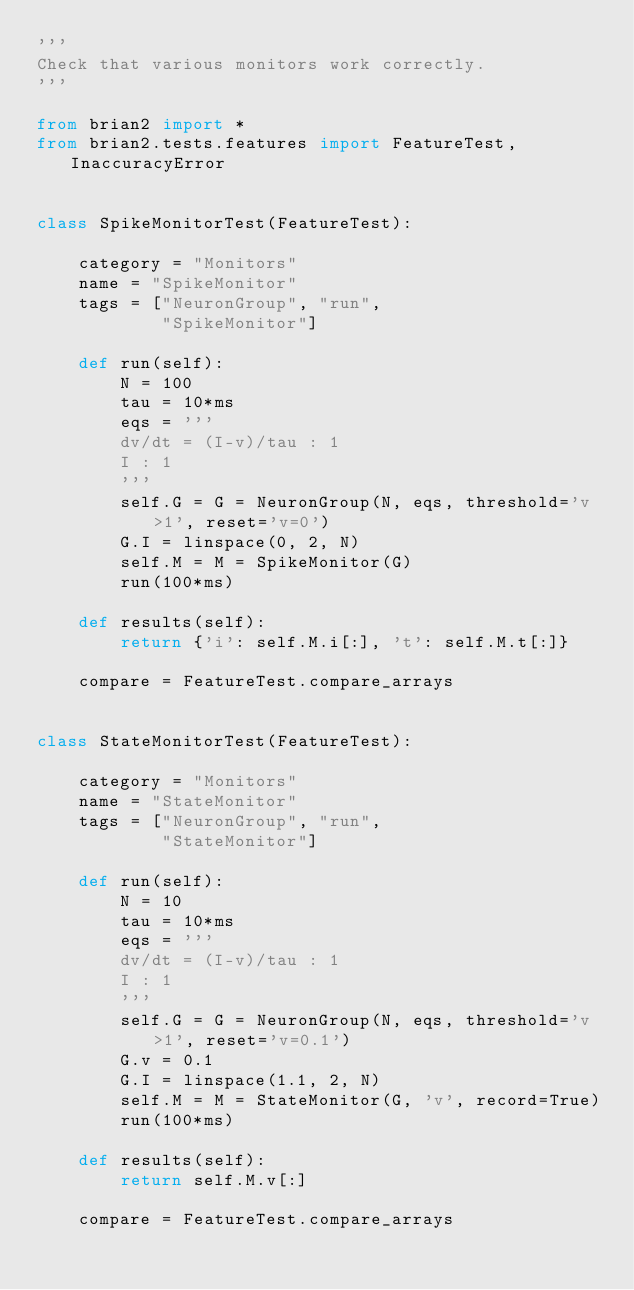Convert code to text. <code><loc_0><loc_0><loc_500><loc_500><_Python_>'''
Check that various monitors work correctly.
'''

from brian2 import *
from brian2.tests.features import FeatureTest, InaccuracyError


class SpikeMonitorTest(FeatureTest):
    
    category = "Monitors"
    name = "SpikeMonitor"
    tags = ["NeuronGroup", "run",
            "SpikeMonitor"]
    
    def run(self):
        N = 100
        tau = 10*ms
        eqs = '''
        dv/dt = (I-v)/tau : 1
        I : 1
        '''
        self.G = G = NeuronGroup(N, eqs, threshold='v>1', reset='v=0')
        G.I = linspace(0, 2, N)
        self.M = M = SpikeMonitor(G)
        run(100*ms)
        
    def results(self):
        return {'i': self.M.i[:], 't': self.M.t[:]}
            
    compare = FeatureTest.compare_arrays


class StateMonitorTest(FeatureTest):
    
    category = "Monitors"
    name = "StateMonitor"
    tags = ["NeuronGroup", "run",
            "StateMonitor"]
    
    def run(self):
        N = 10
        tau = 10*ms
        eqs = '''
        dv/dt = (I-v)/tau : 1
        I : 1
        '''
        self.G = G = NeuronGroup(N, eqs, threshold='v>1', reset='v=0.1')
        G.v = 0.1
        G.I = linspace(1.1, 2, N)
        self.M = M = StateMonitor(G, 'v', record=True)
        run(100*ms)
        
    def results(self):
        return self.M.v[:]
            
    compare = FeatureTest.compare_arrays
</code> 